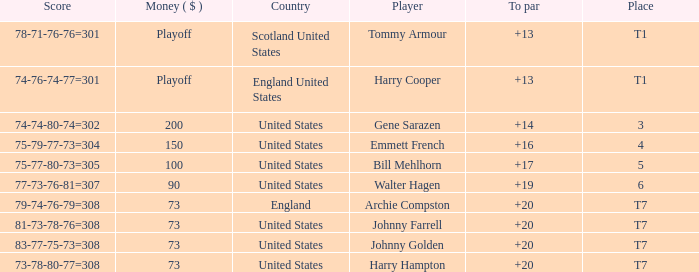What is the ranking for the United States when the money is $200? 3.0. 